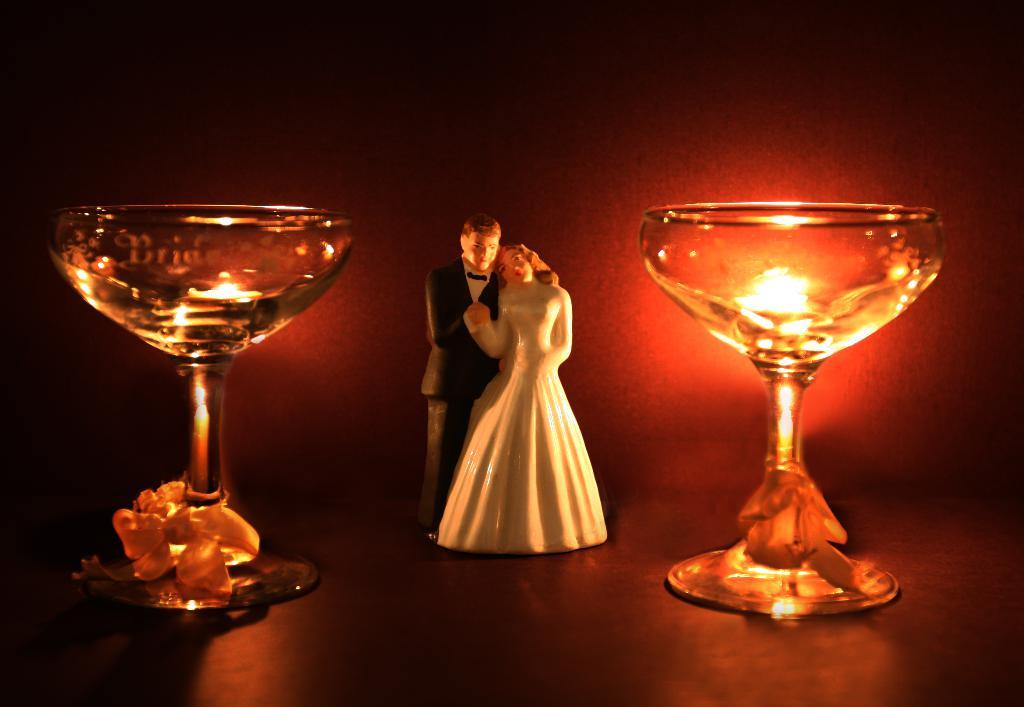What is the main subject of the image? There are two sculptures in the center of the image. What else can be seen around the sculptures? There are glasses on both sides of the sculptures. Is there any source of light in the image? Yes, there is a light on the right side of the image. What type of clover is growing near the sculptures in the image? There is no clover present in the image. What topics are being discussed by the sculptures in the image? Sculptures are inanimate objects and cannot engage in discussions. 